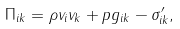<formula> <loc_0><loc_0><loc_500><loc_500>\Pi _ { i k } = \rho v _ { i } v _ { k } + p g _ { i k } - \sigma ^ { \prime } _ { i k } ,</formula> 